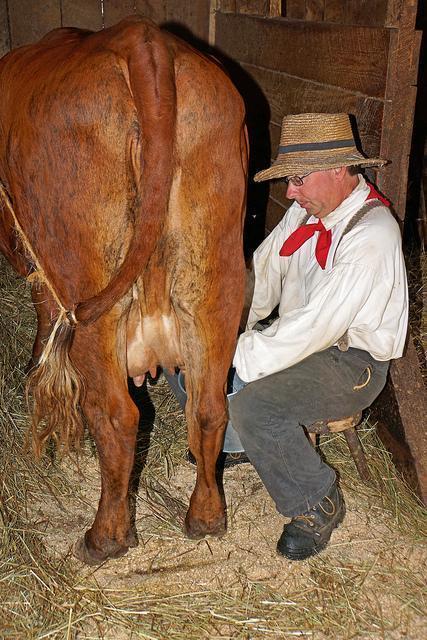What activity is this man involved in?
Choose the correct response and explain in the format: 'Answer: answer
Rationale: rationale.'
Options: Milking, sleeping, examination, sales. Answer: milking.
Rationale: This man's hand's are oriented towards a cow's udders; he sit's on a short stool and we can see a metal pail below the udders. this set of circumstances is associated from taking milk out of a cow. 